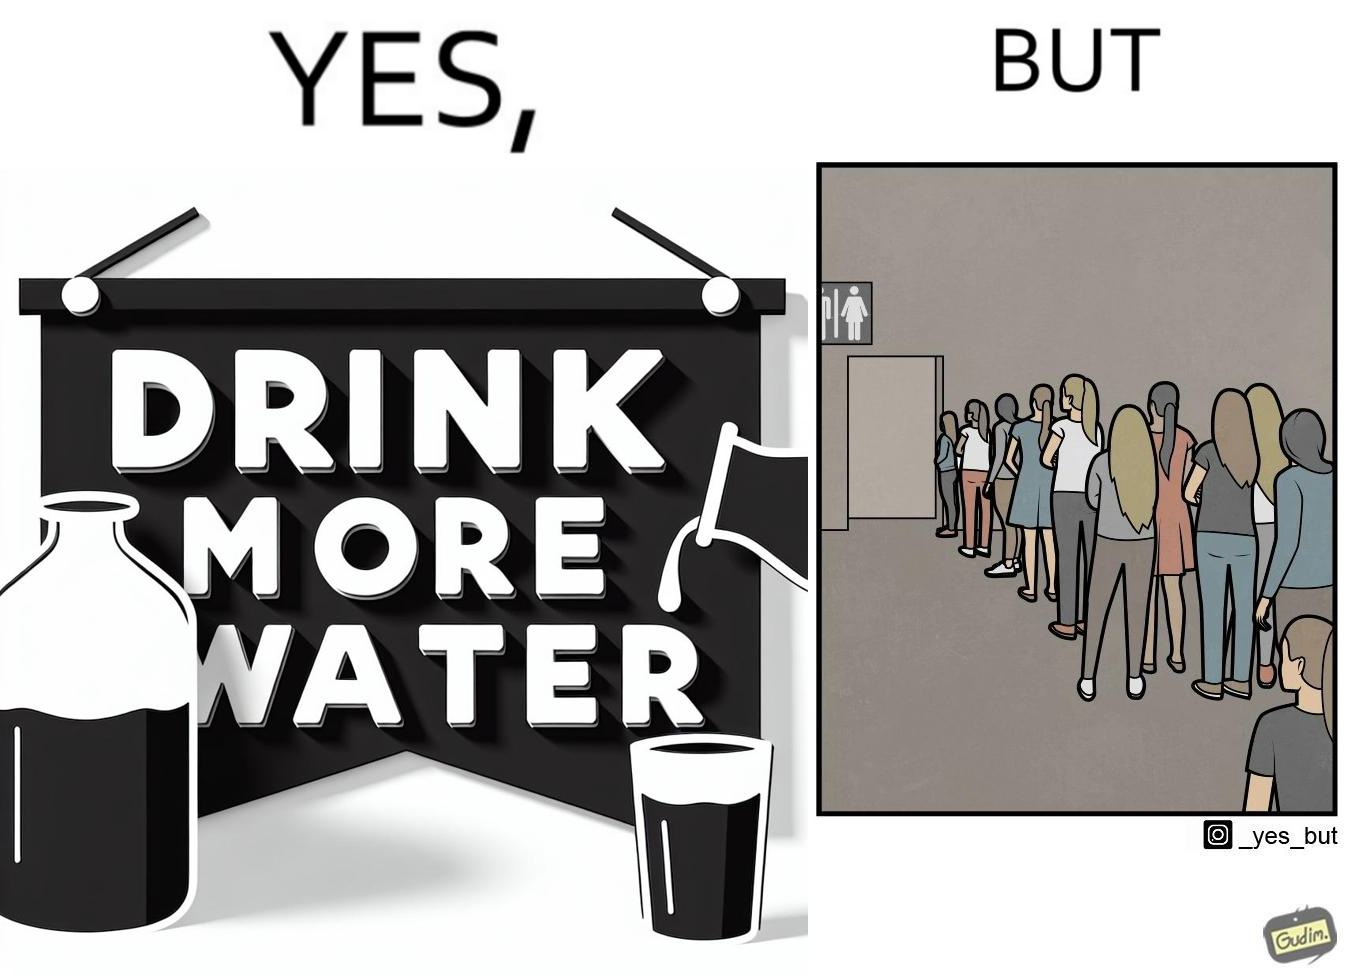Explain the humor or irony in this image. The image is ironical, as the message "Drink more water" is meant to improve health, but in turn, it would lead to longer queues in front of public toilets, leading to people holding urine for longer periods, in turn leading to deterioration in health. 